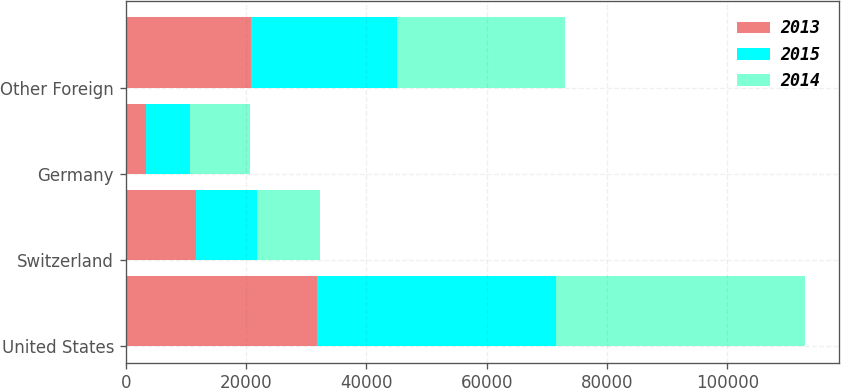Convert chart. <chart><loc_0><loc_0><loc_500><loc_500><stacked_bar_chart><ecel><fcel>United States<fcel>Switzerland<fcel>Germany<fcel>Other Foreign<nl><fcel>2013<fcel>31828<fcel>11681<fcel>3436<fcel>20757<nl><fcel>2015<fcel>39609<fcel>10118<fcel>7174<fcel>24300<nl><fcel>2014<fcel>41427<fcel>10467<fcel>10029<fcel>27881<nl></chart> 